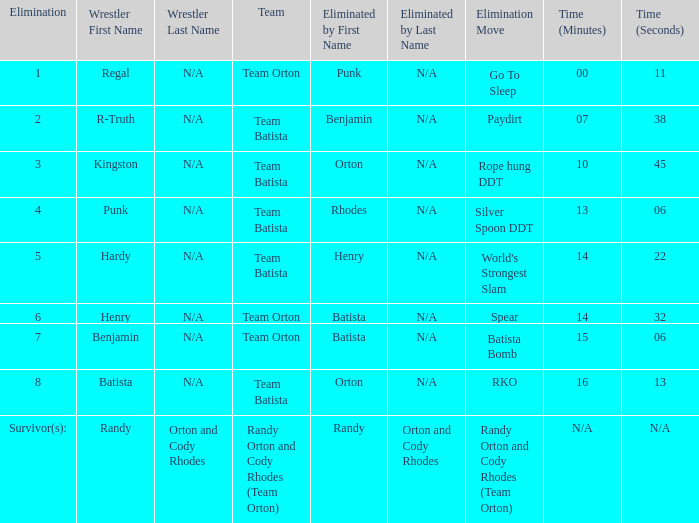What Elimination Move is listed against Wrestler Henry, Eliminated by Batista? Spear. 